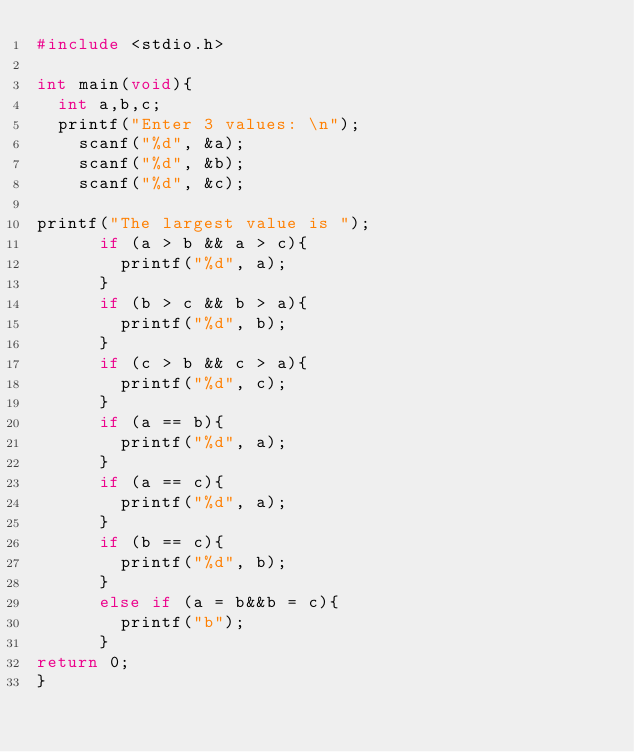<code> <loc_0><loc_0><loc_500><loc_500><_C_>#include <stdio.h>

int main(void){
  int a,b,c;
  printf("Enter 3 values: \n");
    scanf("%d", &a);
    scanf("%d", &b);
    scanf("%d", &c);

printf("The largest value is ");
      if (a > b && a > c){
        printf("%d", a);
      }
      if (b > c && b > a){
        printf("%d", b);
      }
      if (c > b && c > a){
        printf("%d", c);
      }
      if (a == b){
        printf("%d", a);
      }
      if (a == c){
        printf("%d", a);
      }
      if (b == c){
        printf("%d", b);
      }
      else if (a = b&&b = c){
        printf("b");
      }
return 0;
}
</code> 